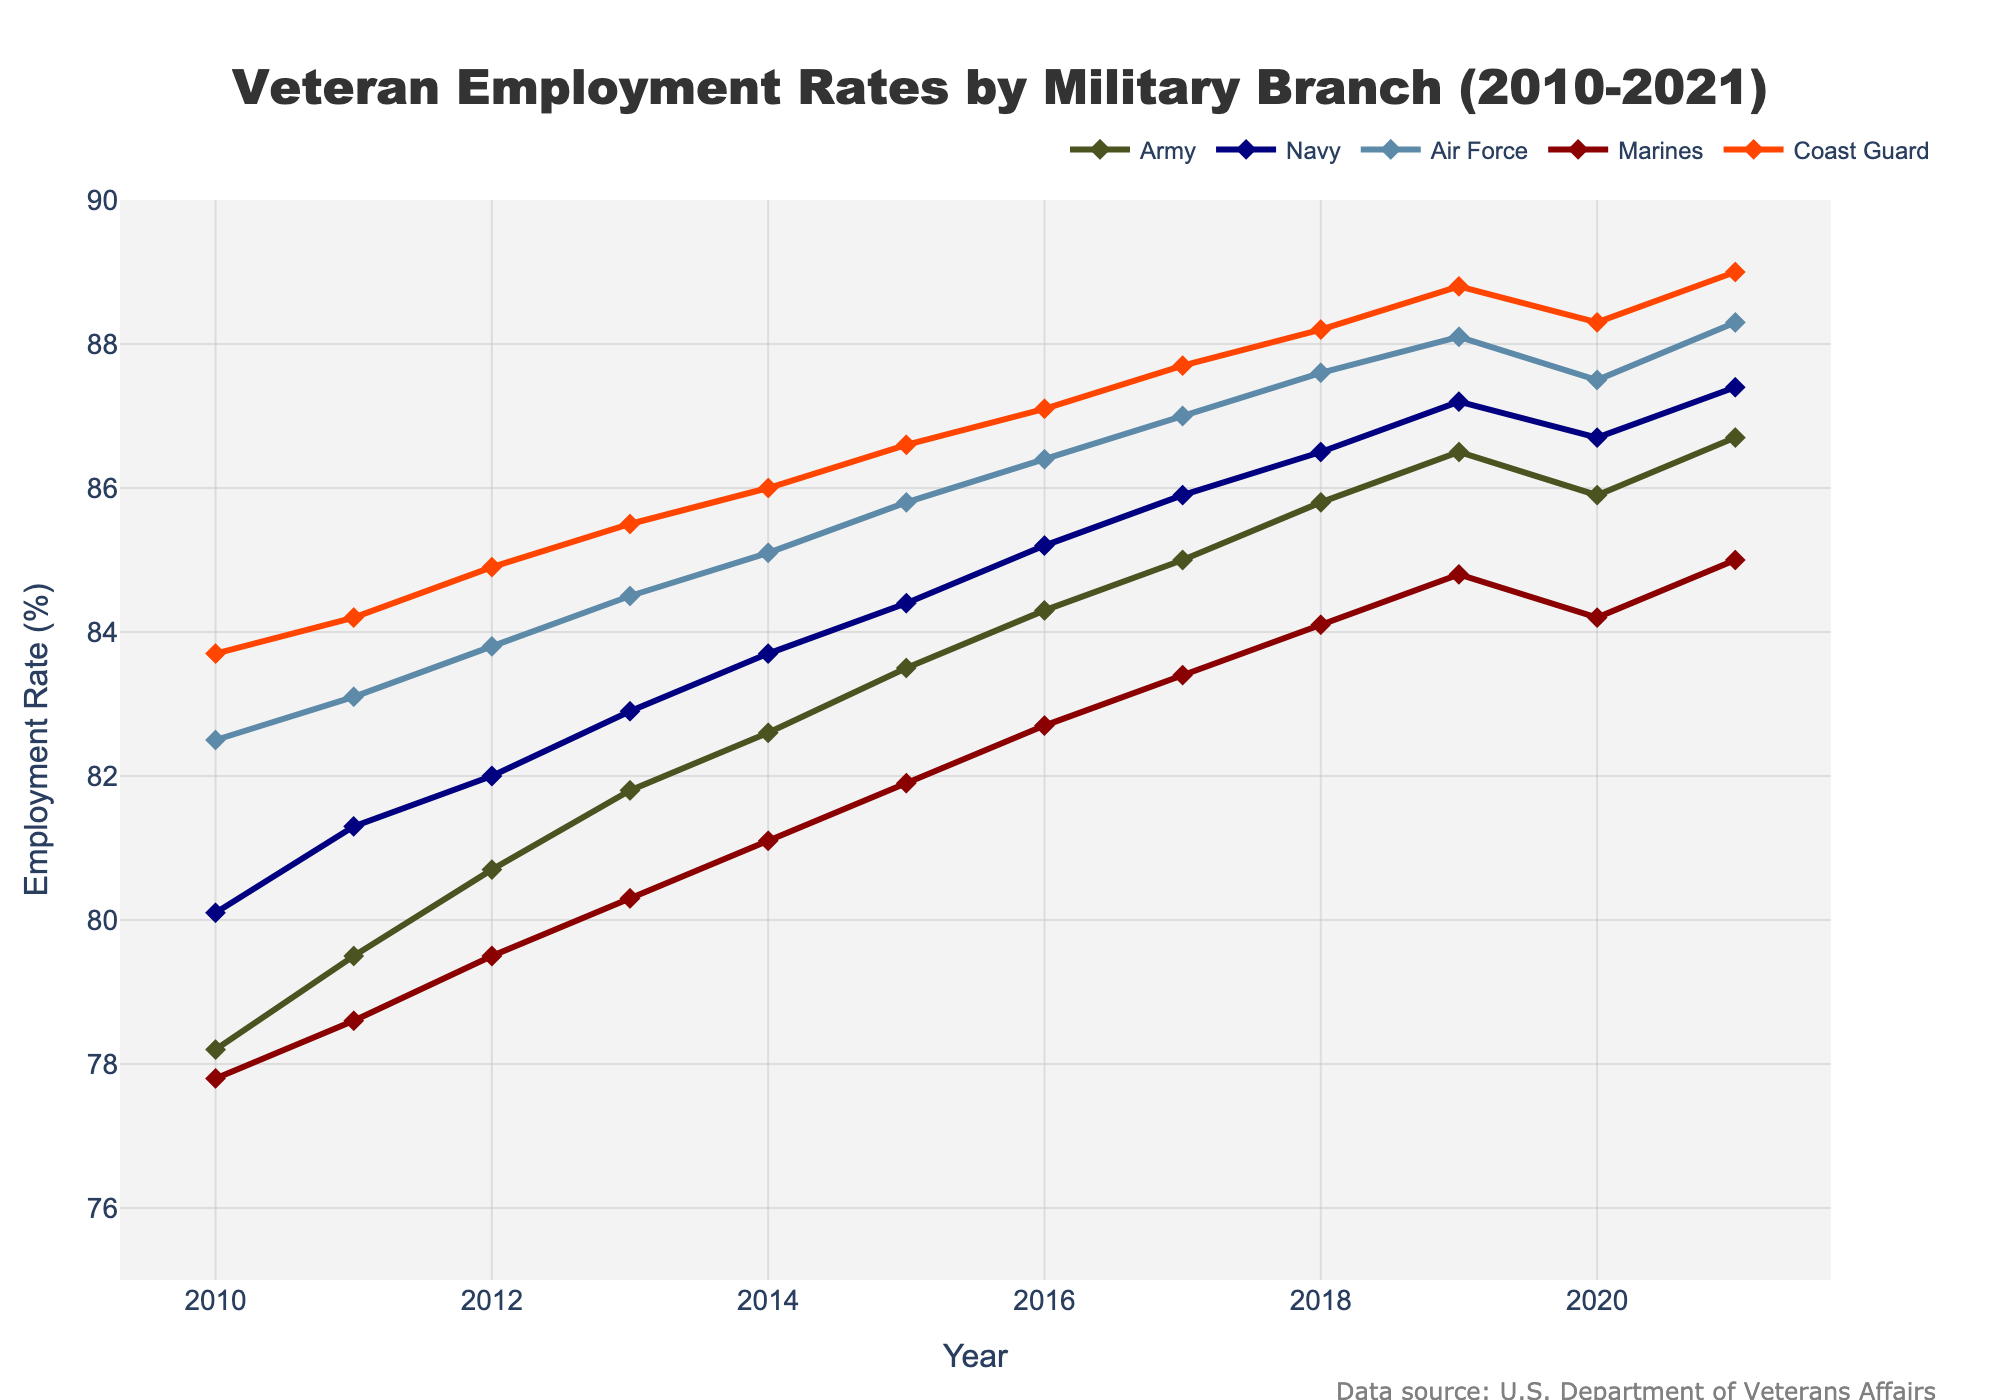What was the employment rate for the Coast Guard in 2016? Locate the data point for the Coast Guard in 2016 on the line chart. The employment rate for the Coast Guard in 2016 is 87.1%.
Answer: 87.1% How did the employment rate for the Air Force change from 2019 to 2020? Compare the rates for the Air Force in 2019 and 2020. It decreased from 88.1% in 2019 to 87.5% in 2020.
Answer: Decreased by 0.6% Which military branch had the highest employment rate in 2021? Identify the highest data point in 2021 among all branches. The Coast Guard had the highest employment rate in 2021 at 89.0%.
Answer: Coast Guard What is the average employment rate for the Marines from 2010 to 2021? Sum the employment rates for the Marines from 2010 to 2021 and divide by the number of years (12). (77.8 + 78.6 + 79.5 + 80.3 + 81.1 + 81.9 + 82.7 + 83.4 + 84.1 + 84.8 + 84.2 + 85.0) / 12 = 81.67%
Answer: 81.67% Which two branches saw an increase in employment rate each year over the period? Check the plot lines for each branch to see which ones are consistently rising every year. The Army and Coast Guard saw an increase in employment rate every year from 2010 to 2021.
Answer: Army and Coast Guard What is the overall trend for the Navy’s employment rate from 2010 to 2021? Observe the direction and shape of the Navy’s line in the chart from 2010 to 2021. The trend shows a consistent increase over the years.
Answer: Increasing Between 2010 and 2020, which branch had the largest overall gain in employment rate? Calculate the difference in employment rate from 2010 to 2020 for each branch and compare. Coast Guard: 88.3 - 83.7 = 4.6, Air Force: 87.5 - 82.5 = 5, Marines: 84.2 - 77.8 = 6.4, Navy: 86.7 - 80.1 = 6.6, Army: 85.9 - 78.2 = 7.7. The largest gain was in the Army with a 7.7% increase.
Answer: Army What was the difference in employment rate between the Army and the Navy in 2011? Subtract the Navy's employment rate from the Army's in 2011. 79.5% (Army) - 81.3% (Navy) = -1.8%.
Answer: -1.8% Which branch showed the least fluctuation in employment rate over the years? Examine the plot lines for each branch and look for the one with the smallest variation. The Coast Guard has the least fluctuation, showing a steady increase with minimal dips.
Answer: Coast Guard How does the employment rate for the Air Force in 2018 compare to the Army in the same year? Compare the data points for both branches in 2018. The Air Force had an employment rate of 87.6%, while the Army had 85.8%. The Air Force had a higher employment rate in 2018.
Answer: Air Force had higher rate 